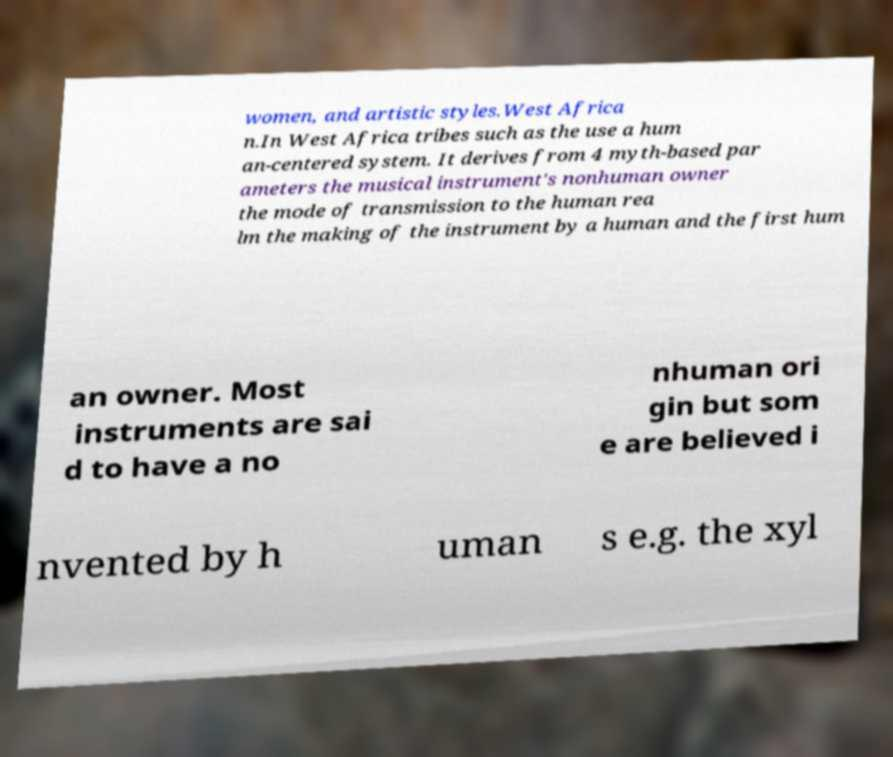I need the written content from this picture converted into text. Can you do that? women, and artistic styles.West Africa n.In West Africa tribes such as the use a hum an-centered system. It derives from 4 myth-based par ameters the musical instrument's nonhuman owner the mode of transmission to the human rea lm the making of the instrument by a human and the first hum an owner. Most instruments are sai d to have a no nhuman ori gin but som e are believed i nvented by h uman s e.g. the xyl 